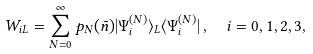<formula> <loc_0><loc_0><loc_500><loc_500>W _ { i L } = \sum _ { N { = } 0 } ^ { \infty } p _ { N } ( \bar { n } ) | \Psi ^ { ( N ) } _ { i } \rangle _ { L } \langle \Psi ^ { ( N ) } _ { i } | \, , \ \ i = 0 , 1 , 2 , 3 ,</formula> 